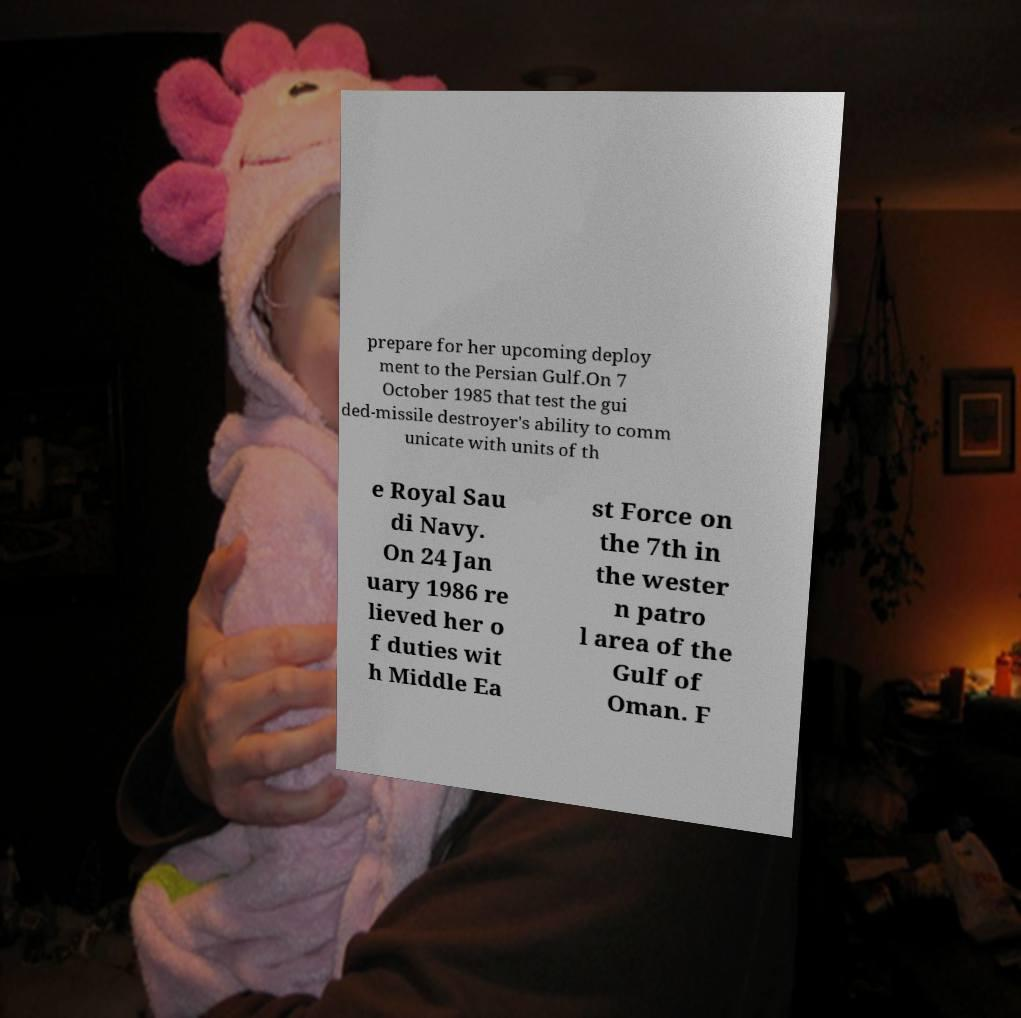Could you extract and type out the text from this image? prepare for her upcoming deploy ment to the Persian Gulf.On 7 October 1985 that test the gui ded-missile destroyer's ability to comm unicate with units of th e Royal Sau di Navy. On 24 Jan uary 1986 re lieved her o f duties wit h Middle Ea st Force on the 7th in the wester n patro l area of the Gulf of Oman. F 